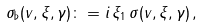Convert formula to latex. <formula><loc_0><loc_0><loc_500><loc_500>\sigma _ { \flat } ( v , \xi , \gamma ) \colon = i \, \xi _ { 1 } \, \sigma ( v , \xi , \gamma ) \, ,</formula> 